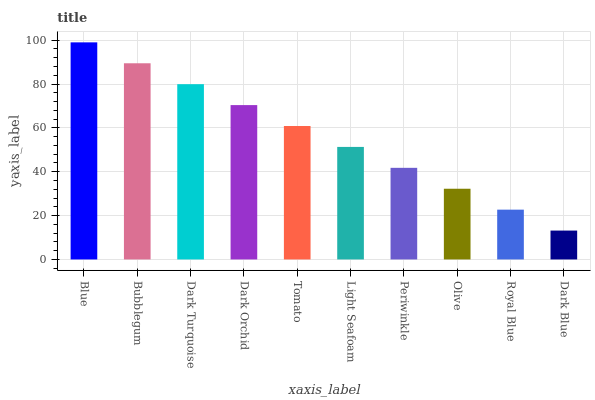Is Dark Blue the minimum?
Answer yes or no. Yes. Is Blue the maximum?
Answer yes or no. Yes. Is Bubblegum the minimum?
Answer yes or no. No. Is Bubblegum the maximum?
Answer yes or no. No. Is Blue greater than Bubblegum?
Answer yes or no. Yes. Is Bubblegum less than Blue?
Answer yes or no. Yes. Is Bubblegum greater than Blue?
Answer yes or no. No. Is Blue less than Bubblegum?
Answer yes or no. No. Is Tomato the high median?
Answer yes or no. Yes. Is Light Seafoam the low median?
Answer yes or no. Yes. Is Olive the high median?
Answer yes or no. No. Is Periwinkle the low median?
Answer yes or no. No. 